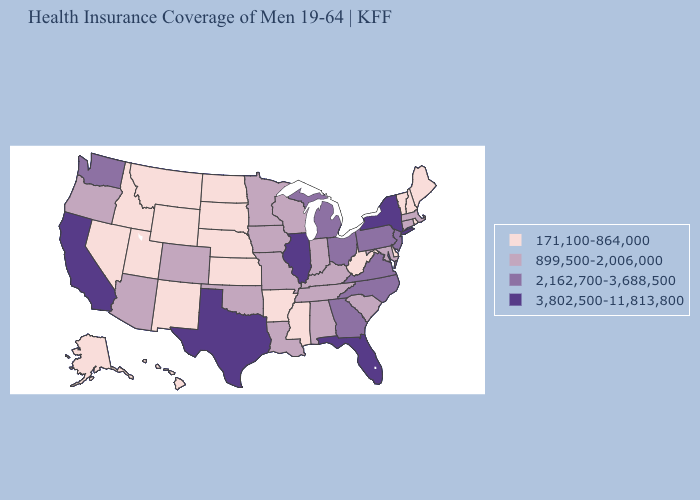Does Tennessee have the same value as Utah?
Write a very short answer. No. What is the highest value in states that border Nevada?
Quick response, please. 3,802,500-11,813,800. What is the value of Ohio?
Concise answer only. 2,162,700-3,688,500. Name the states that have a value in the range 171,100-864,000?
Answer briefly. Alaska, Arkansas, Delaware, Hawaii, Idaho, Kansas, Maine, Mississippi, Montana, Nebraska, Nevada, New Hampshire, New Mexico, North Dakota, Rhode Island, South Dakota, Utah, Vermont, West Virginia, Wyoming. What is the value of Arizona?
Short answer required. 899,500-2,006,000. Name the states that have a value in the range 3,802,500-11,813,800?
Short answer required. California, Florida, Illinois, New York, Texas. What is the lowest value in the South?
Short answer required. 171,100-864,000. Does Colorado have the lowest value in the West?
Write a very short answer. No. Among the states that border New Hampshire , does Massachusetts have the highest value?
Concise answer only. Yes. What is the value of Nebraska?
Short answer required. 171,100-864,000. Among the states that border Minnesota , does South Dakota have the highest value?
Short answer required. No. Name the states that have a value in the range 2,162,700-3,688,500?
Be succinct. Georgia, Michigan, New Jersey, North Carolina, Ohio, Pennsylvania, Virginia, Washington. Which states have the lowest value in the USA?
Keep it brief. Alaska, Arkansas, Delaware, Hawaii, Idaho, Kansas, Maine, Mississippi, Montana, Nebraska, Nevada, New Hampshire, New Mexico, North Dakota, Rhode Island, South Dakota, Utah, Vermont, West Virginia, Wyoming. What is the value of Maryland?
Write a very short answer. 899,500-2,006,000. Name the states that have a value in the range 3,802,500-11,813,800?
Short answer required. California, Florida, Illinois, New York, Texas. 